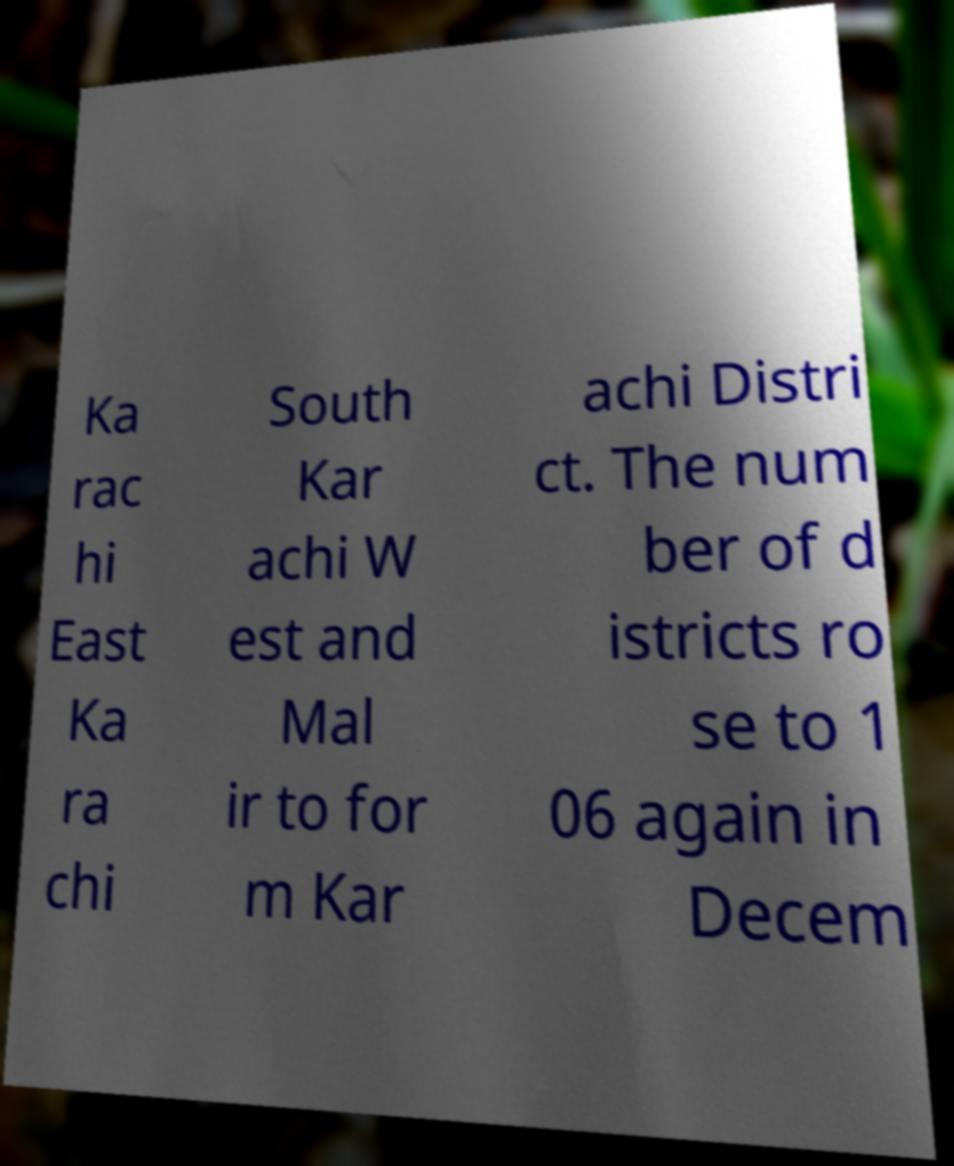Could you extract and type out the text from this image? Ka rac hi East Ka ra chi South Kar achi W est and Mal ir to for m Kar achi Distri ct. The num ber of d istricts ro se to 1 06 again in Decem 